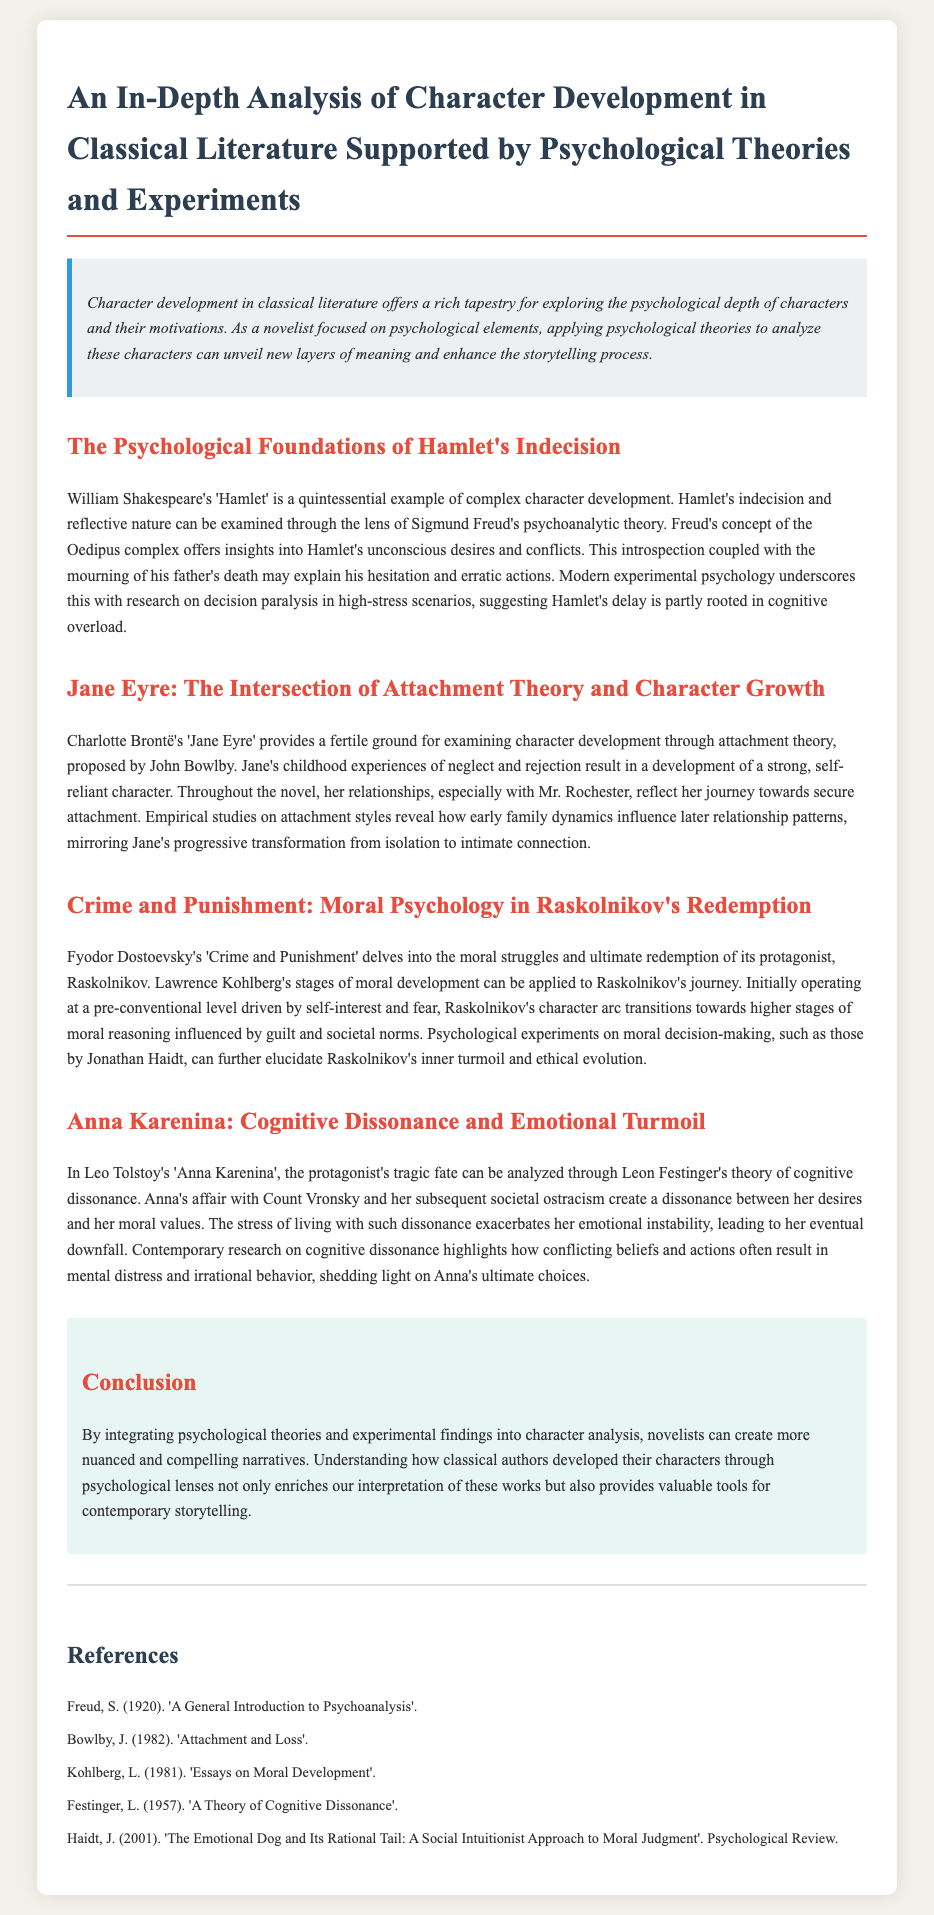What is the title of the document? The title is mentioned in the header section of the document as "An In-Depth Analysis of Character Development in Classical Literature Supported by Psychological Theories and Experiments."
Answer: An In-Depth Analysis of Character Development in Classical Literature Supported by Psychological Theories and Experiments Who is the author of 'Jane Eyre'? The document refers to Charlotte Brontë as the author of 'Jane Eyre.'
Answer: Charlotte Brontë What psychological theory is applied to Hamlet's character? The document states that Hamlet's character is examined through the lens of Sigmund Freud's psychoanalytic theory.
Answer: Sigmund Freud's psychoanalytic theory Which character experiences emotional turmoil due to cognitive dissonance? The document discusses Anna Karenina as the character experiencing emotional turmoil due to cognitive dissonance.
Answer: Anna Karenina What stage of moral development does Raskolnikov initially operate at? The document indicates that Raskolnikov initially operates at a pre-conventional level of moral development.
Answer: Pre-conventional How does Jane Eyre's character develop throughout the story? The document states that Jane Eyre's relationships reflect her journey towards secure attachment, demonstrating her progressive transformation.
Answer: Journey towards secure attachment What concept does modern experimental psychology relate to Hamlet's indecision? Modern experimental psychology relates Hamlet's indecision to research on decision paralysis in high-stress scenarios.
Answer: Decision paralysis Which author wrote 'Crime and Punishment'? The document identifies Fyodor Dostoevsky as the author of 'Crime and Punishment.'
Answer: Fyodor Dostoevsky 